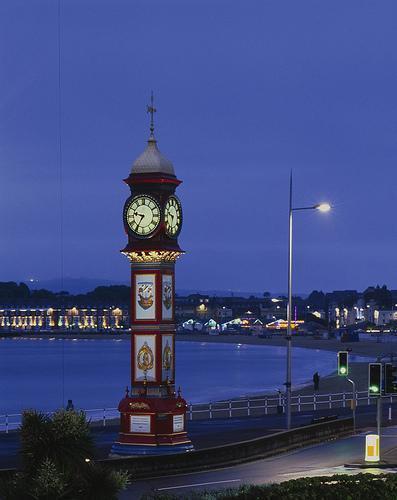How many clocks are shown?
Give a very brief answer. 2. 